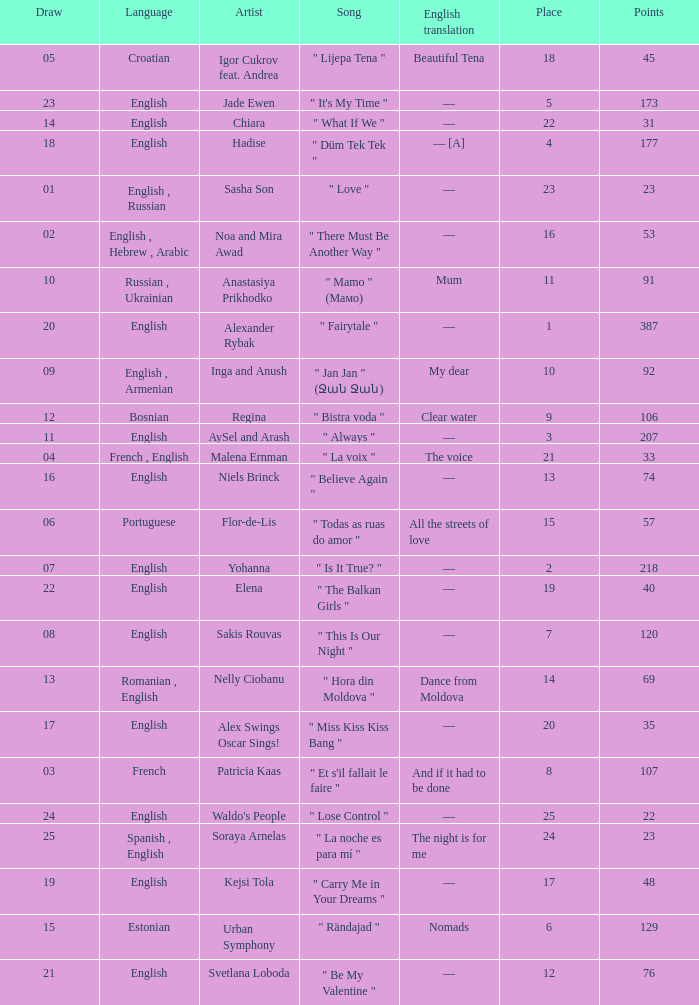What was the english translation for the song by svetlana loboda? —. 